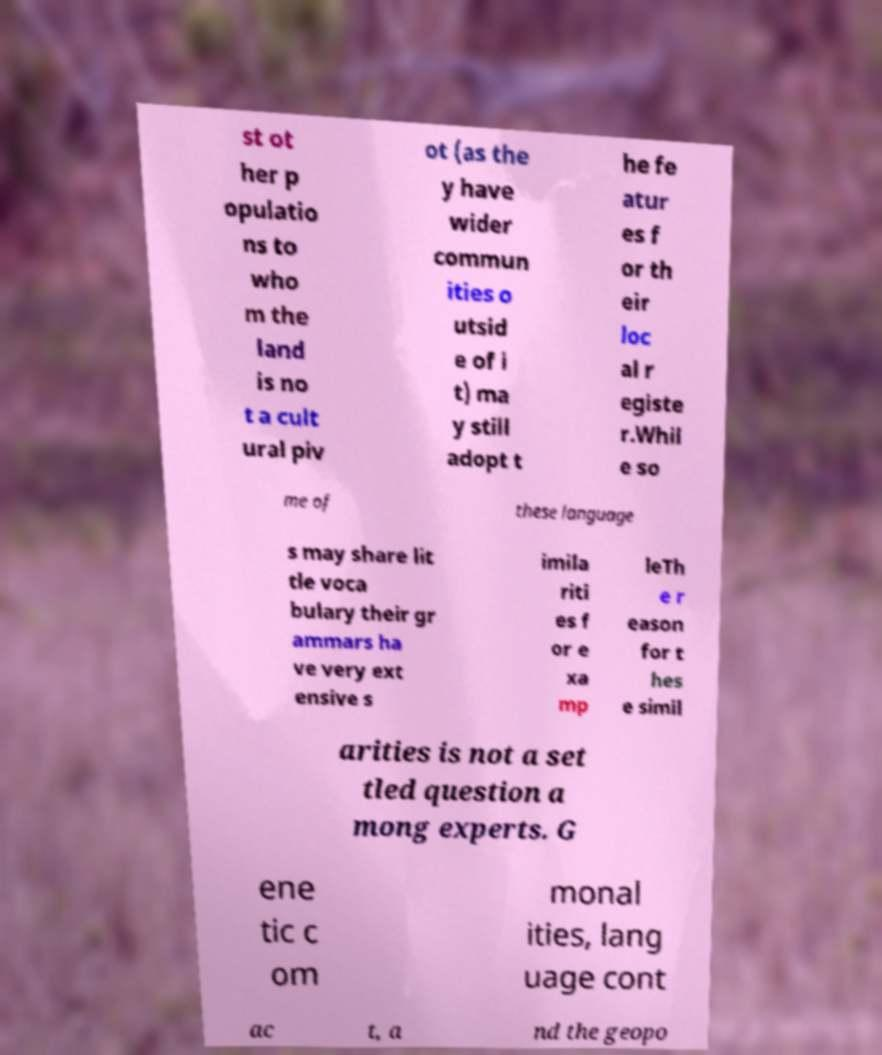Can you accurately transcribe the text from the provided image for me? st ot her p opulatio ns to who m the land is no t a cult ural piv ot (as the y have wider commun ities o utsid e of i t) ma y still adopt t he fe atur es f or th eir loc al r egiste r.Whil e so me of these language s may share lit tle voca bulary their gr ammars ha ve very ext ensive s imila riti es f or e xa mp leTh e r eason for t hes e simil arities is not a set tled question a mong experts. G ene tic c om monal ities, lang uage cont ac t, a nd the geopo 